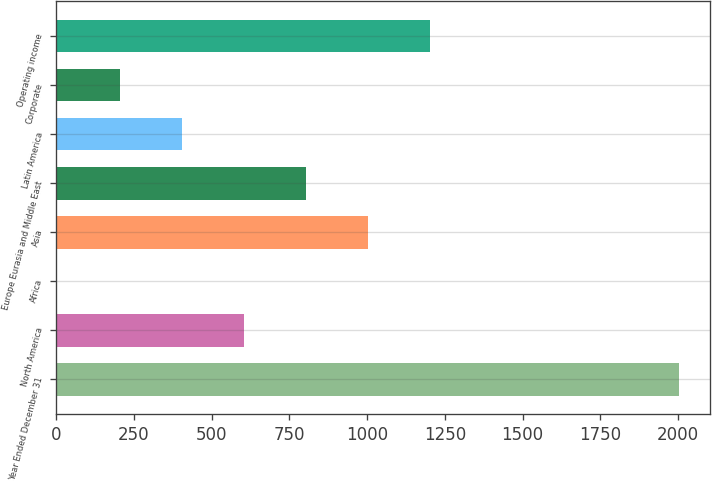Convert chart. <chart><loc_0><loc_0><loc_500><loc_500><bar_chart><fcel>Year Ended December 31<fcel>North America<fcel>Africa<fcel>Asia<fcel>Europe Eurasia and Middle East<fcel>Latin America<fcel>Corporate<fcel>Operating income<nl><fcel>2002<fcel>603.47<fcel>4.1<fcel>1003.05<fcel>803.26<fcel>403.68<fcel>203.89<fcel>1202.84<nl></chart> 